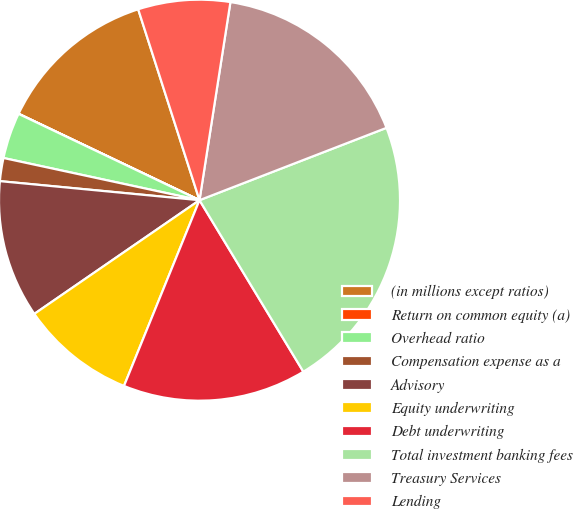Convert chart. <chart><loc_0><loc_0><loc_500><loc_500><pie_chart><fcel>(in millions except ratios)<fcel>Return on common equity (a)<fcel>Overhead ratio<fcel>Compensation expense as a<fcel>Advisory<fcel>Equity underwriting<fcel>Debt underwriting<fcel>Total investment banking fees<fcel>Treasury Services<fcel>Lending<nl><fcel>12.96%<fcel>0.01%<fcel>3.71%<fcel>1.86%<fcel>11.11%<fcel>9.26%<fcel>14.81%<fcel>22.21%<fcel>16.66%<fcel>7.41%<nl></chart> 